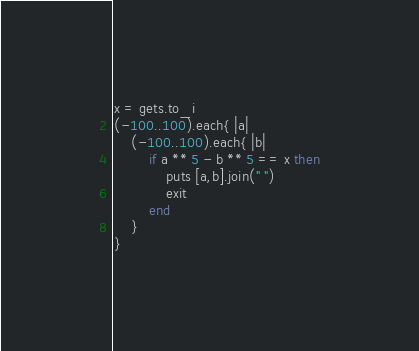<code> <loc_0><loc_0><loc_500><loc_500><_Ruby_>x = gets.to_i
(-100..100).each{ |a|
	(-100..100).each{ |b|
		if a ** 5 - b ** 5 == x then
			puts [a,b].join(" ")
			exit
		end
	}
}</code> 